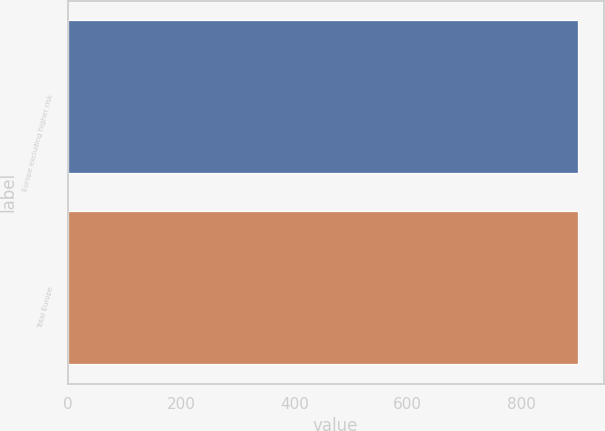Convert chart to OTSL. <chart><loc_0><loc_0><loc_500><loc_500><bar_chart><fcel>Europe excluding higher risk<fcel>Total Europe<nl><fcel>901<fcel>901.1<nl></chart> 